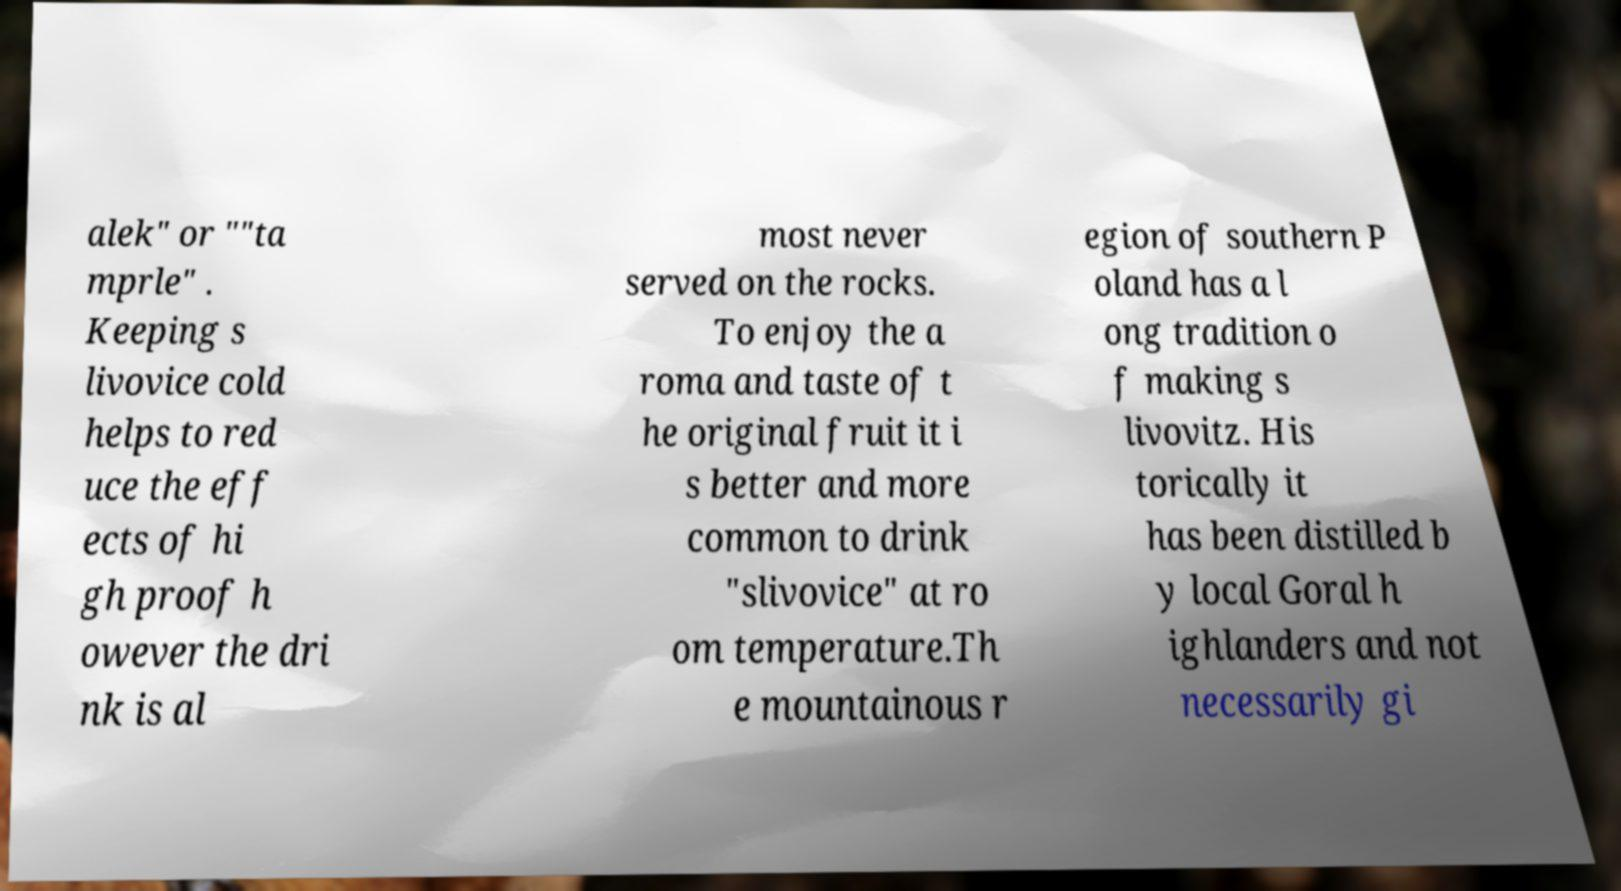What messages or text are displayed in this image? I need them in a readable, typed format. alek" or ""ta mprle" . Keeping s livovice cold helps to red uce the eff ects of hi gh proof h owever the dri nk is al most never served on the rocks. To enjoy the a roma and taste of t he original fruit it i s better and more common to drink "slivovice" at ro om temperature.Th e mountainous r egion of southern P oland has a l ong tradition o f making s livovitz. His torically it has been distilled b y local Goral h ighlanders and not necessarily gi 